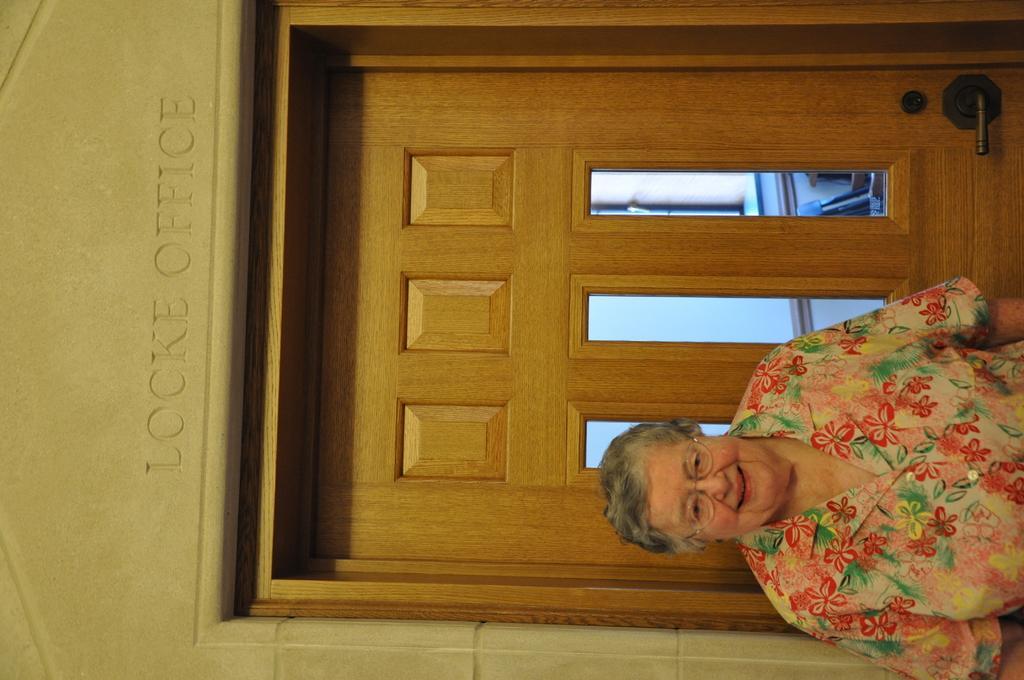Can you describe this image briefly? In this image there is a woman standing in front of a closed door with a smile on her face, above the door on the wall there is some text engraved. 